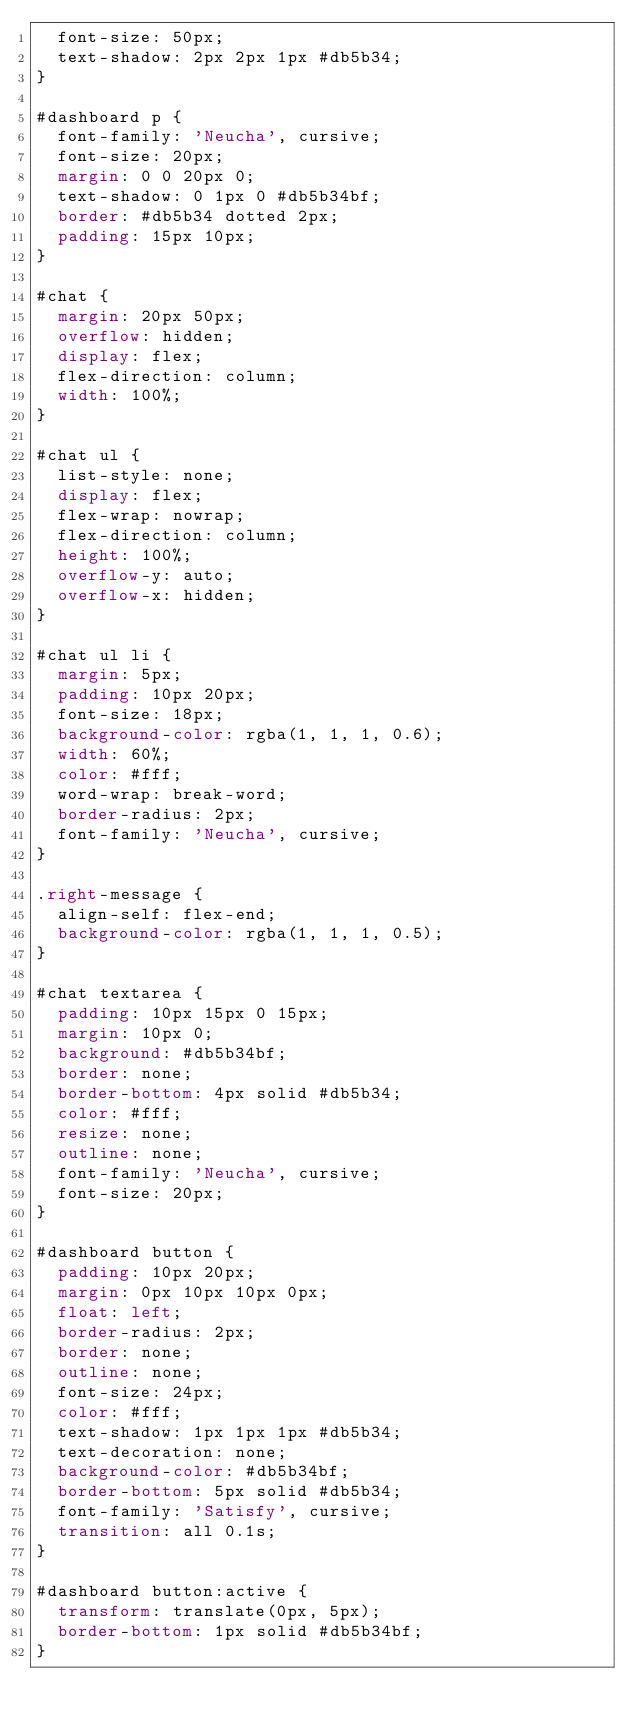Convert code to text. <code><loc_0><loc_0><loc_500><loc_500><_CSS_>  font-size: 50px;
  text-shadow: 2px 2px 1px #db5b34;
}

#dashboard p {
  font-family: 'Neucha', cursive;
  font-size: 20px;
  margin: 0 0 20px 0;
  text-shadow: 0 1px 0 #db5b34bf;
  border: #db5b34 dotted 2px;
  padding: 15px 10px;
}

#chat {
  margin: 20px 50px;
  overflow: hidden;
  display: flex;
  flex-direction: column;
  width: 100%;
}

#chat ul {
  list-style: none;
  display: flex;
  flex-wrap: nowrap;
  flex-direction: column;
  height: 100%;
  overflow-y: auto;
  overflow-x: hidden;
}

#chat ul li {
  margin: 5px;
  padding: 10px 20px;
  font-size: 18px;
  background-color: rgba(1, 1, 1, 0.6);
  width: 60%;
  color: #fff;
  word-wrap: break-word;
  border-radius: 2px;
  font-family: 'Neucha', cursive;
}

.right-message {
  align-self: flex-end;
  background-color: rgba(1, 1, 1, 0.5);
}

#chat textarea {
  padding: 10px 15px 0 15px;
  margin: 10px 0;
  background: #db5b34bf;
  border: none;
  border-bottom: 4px solid #db5b34;
  color: #fff;
  resize: none;
  outline: none;
  font-family: 'Neucha', cursive;
  font-size: 20px;
}

#dashboard button {
  padding: 10px 20px;
  margin: 0px 10px 10px 0px;
  float: left;
  border-radius: 2px;
  border: none;
  outline: none;
  font-size: 24px;
  color: #fff;
  text-shadow: 1px 1px 1px #db5b34;
  text-decoration: none;
  background-color: #db5b34bf;
  border-bottom: 5px solid #db5b34;
  font-family: 'Satisfy', cursive;
  transition: all 0.1s;
}

#dashboard button:active {
  transform: translate(0px, 5px);
  border-bottom: 1px solid #db5b34bf;
}
</code> 